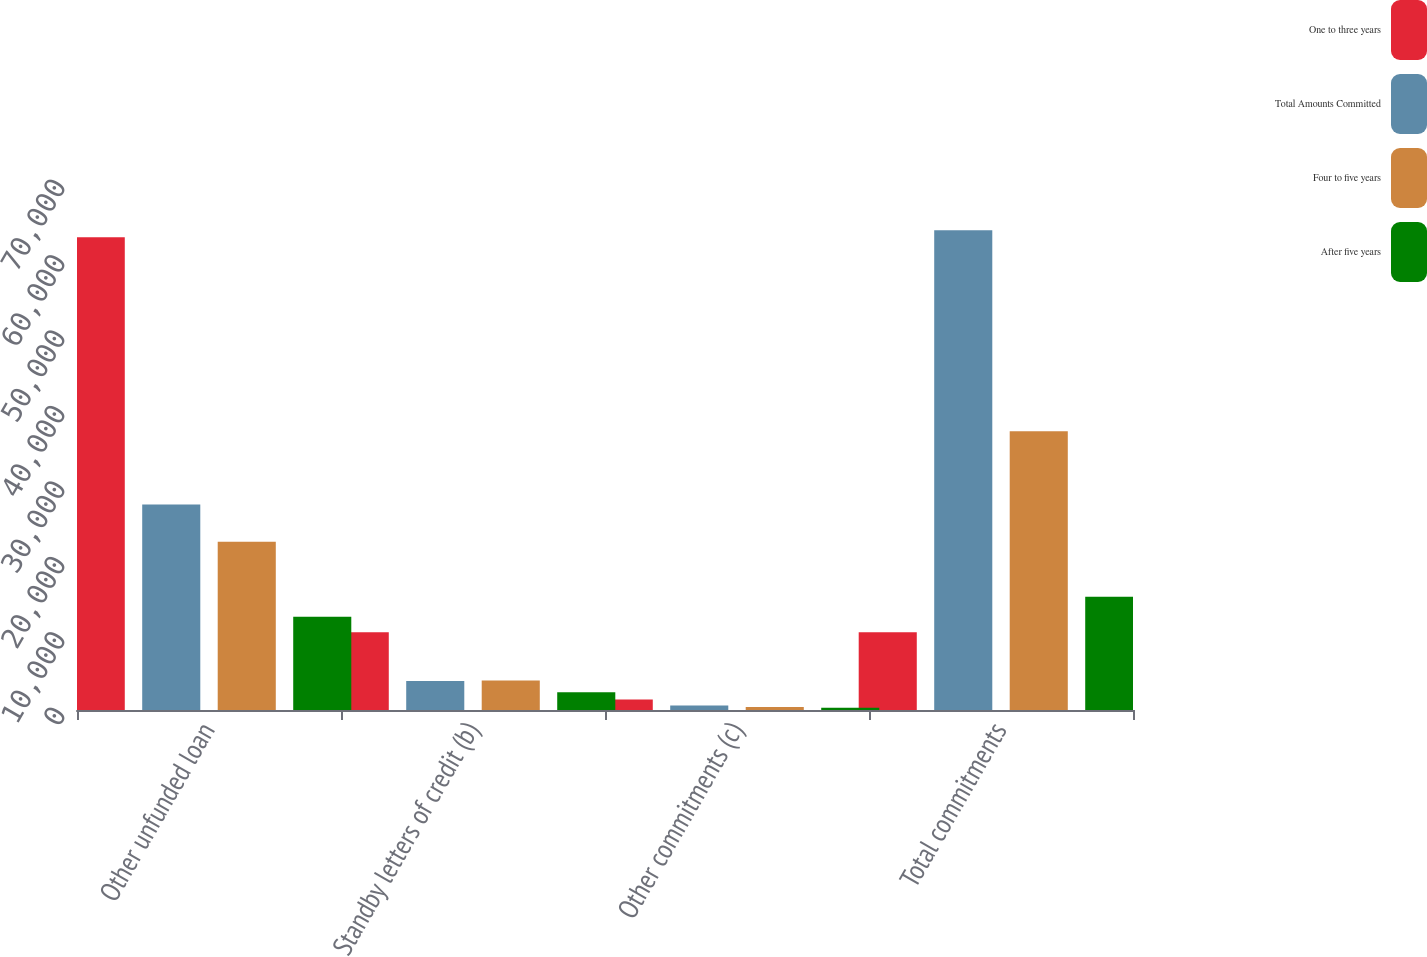Convert chart. <chart><loc_0><loc_0><loc_500><loc_500><stacked_bar_chart><ecel><fcel>Other unfunded loan<fcel>Standby letters of credit (b)<fcel>Other commitments (c)<fcel>Total commitments<nl><fcel>One to three years<fcel>62665<fcel>10317<fcel>1408<fcel>10317<nl><fcel>Total Amounts Committed<fcel>27260<fcel>3855<fcel>595<fcel>63601<nl><fcel>Four to five years<fcel>22317<fcel>3916<fcel>390<fcel>36955<nl><fcel>After five years<fcel>12358<fcel>2352<fcel>302<fcel>15012<nl></chart> 